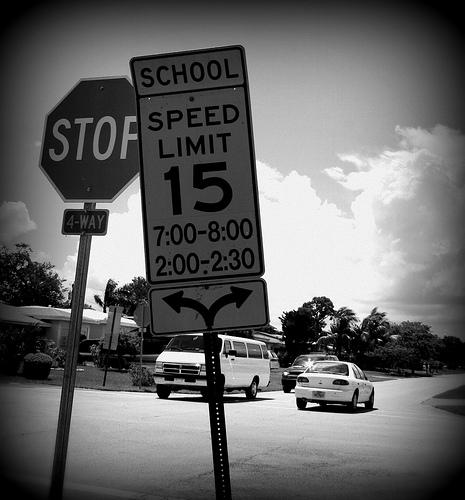Question: why is the speed limit so low?
Choices:
A. It's a school zone.
B. It's a shopping area.
C. It's right by a hospital.
D. It's a dangerous "S" curve.
Answer with the letter. Answer: A Question: what kind of photo is this?
Choices:
A. Antique.
B. Black and white.
C. Landscape.
D. Color.
Answer with the letter. Answer: B Question: how many vehicles are there?
Choices:
A. Four.
B. Two.
C. One.
D. Three.
Answer with the letter. Answer: D 